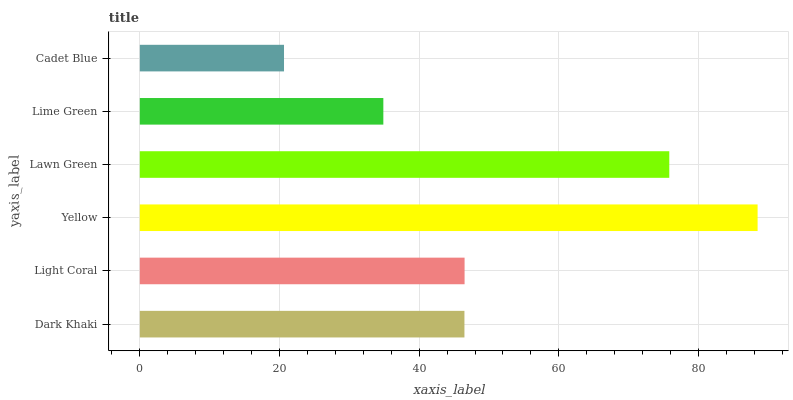Is Cadet Blue the minimum?
Answer yes or no. Yes. Is Yellow the maximum?
Answer yes or no. Yes. Is Light Coral the minimum?
Answer yes or no. No. Is Light Coral the maximum?
Answer yes or no. No. Is Light Coral greater than Dark Khaki?
Answer yes or no. Yes. Is Dark Khaki less than Light Coral?
Answer yes or no. Yes. Is Dark Khaki greater than Light Coral?
Answer yes or no. No. Is Light Coral less than Dark Khaki?
Answer yes or no. No. Is Light Coral the high median?
Answer yes or no. Yes. Is Dark Khaki the low median?
Answer yes or no. Yes. Is Cadet Blue the high median?
Answer yes or no. No. Is Yellow the low median?
Answer yes or no. No. 